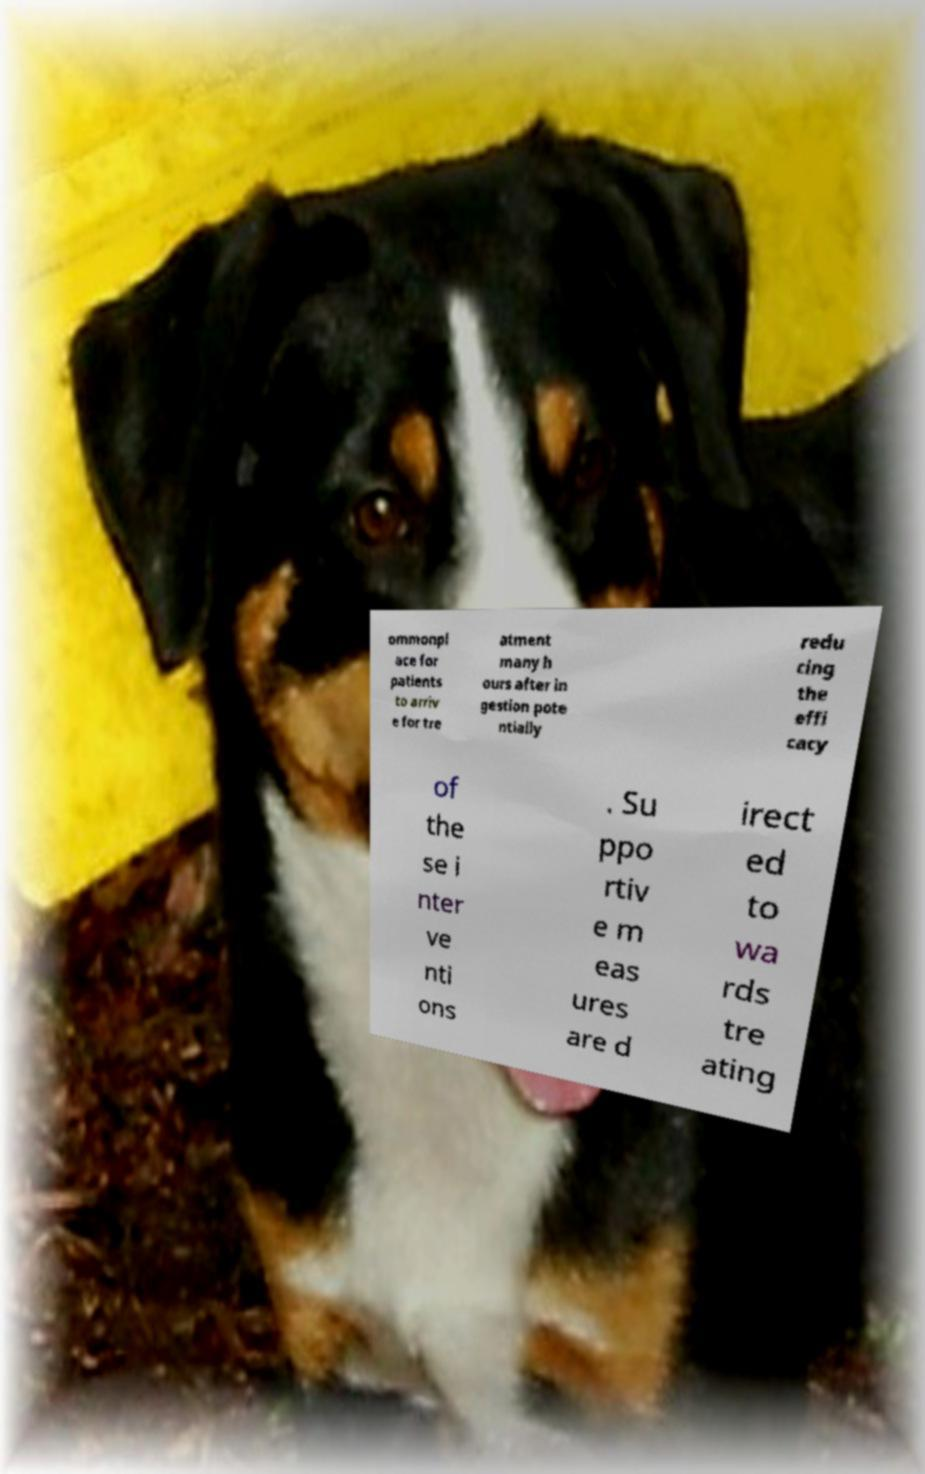Please read and relay the text visible in this image. What does it say? ommonpl ace for patients to arriv e for tre atment many h ours after in gestion pote ntially redu cing the effi cacy of the se i nter ve nti ons . Su ppo rtiv e m eas ures are d irect ed to wa rds tre ating 